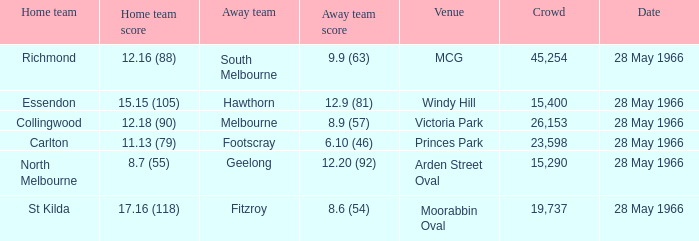Which Venue has a Home team of essendon? Windy Hill. 